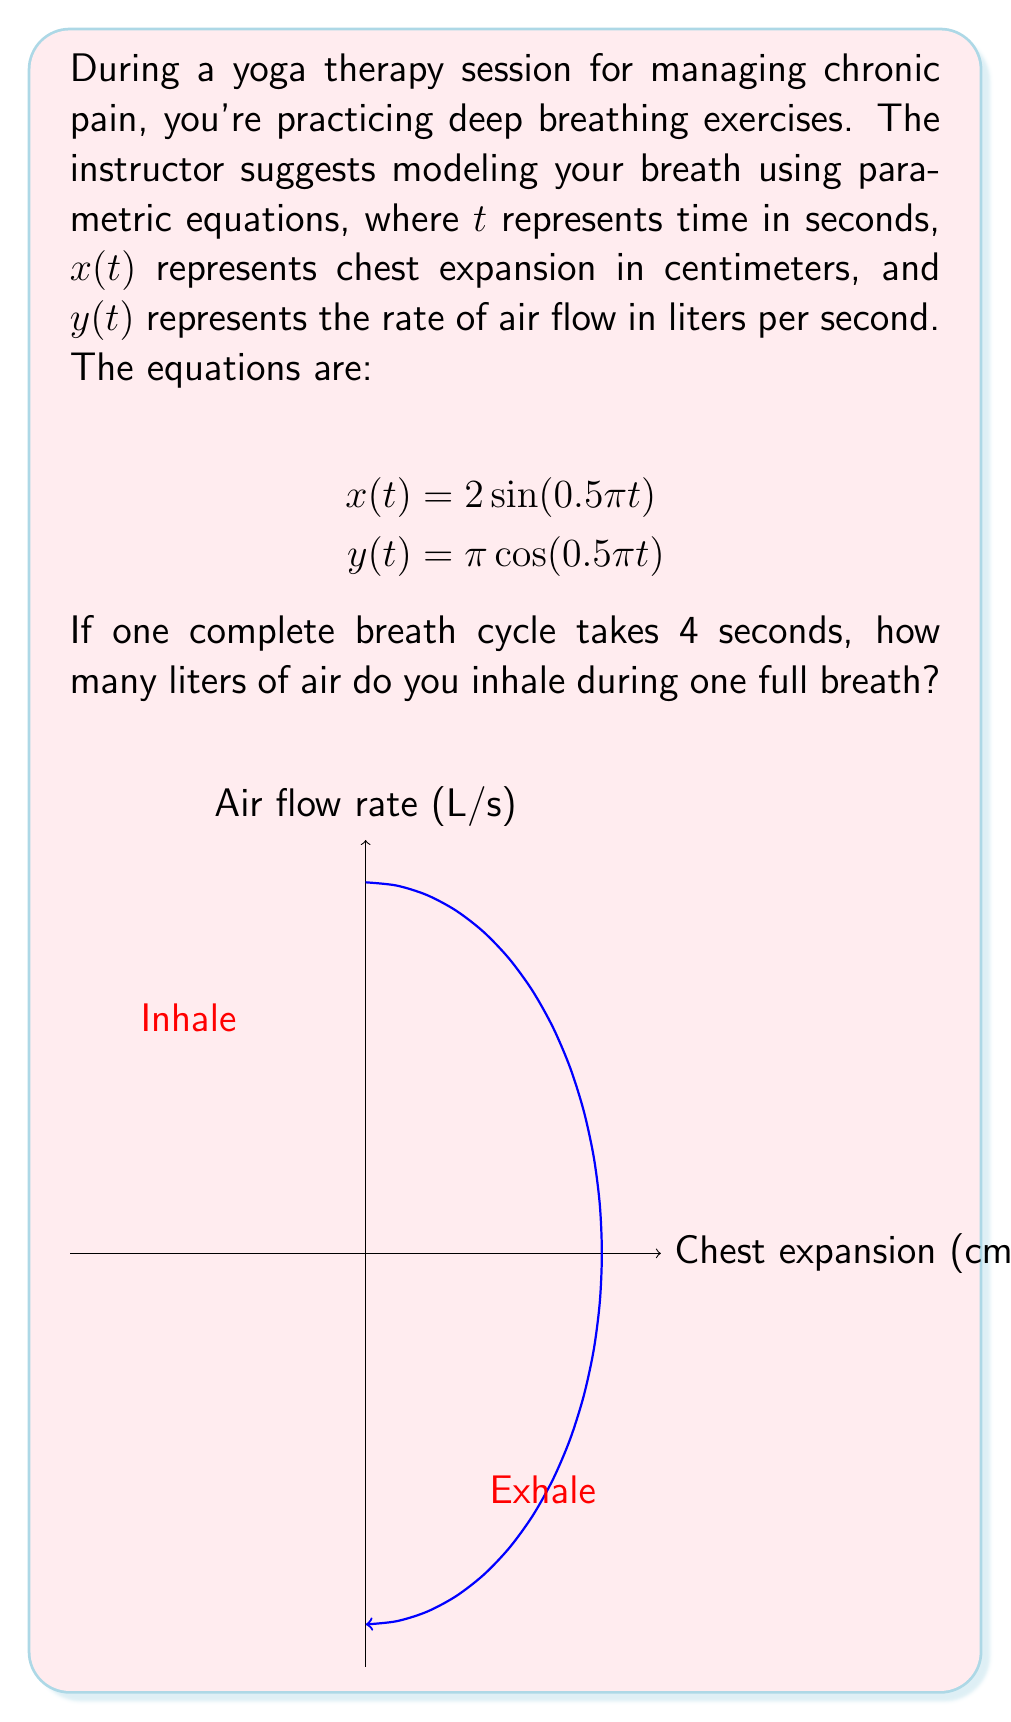What is the answer to this math problem? Let's approach this step-by-step:

1) First, we need to understand what the equations represent:
   - $x(t) = 2 \sin(0.5\pi t)$ represents chest expansion
   - $y(t) = \pi \cos(0.5\pi t)$ represents the rate of air flow

2) We're told that one complete breath cycle takes 4 seconds. This means that $t$ goes from 0 to 4 for a full cycle.

3) To find the volume of air inhaled, we need to integrate the air flow rate over the inhalation period. Inhalation occurs when the air flow rate is positive.

4) The air flow rate $y(t)$ is positive when $\cos(0.5\pi t)$ is positive, which is from $t=0$ to $t=2$ (half of the full cycle).

5) So, we need to integrate $y(t)$ from $t=0$ to $t=2$:

   $$\text{Volume} = \int_0^2 y(t) dt = \int_0^2 \pi \cos(0.5\pi t) dt$$

6) Solving this integral:
   $$\begin{align}
   \text{Volume} &= \pi \int_0^2 \cos(0.5\pi t) dt \\
   &= \pi \cdot \frac{2}{0.5\pi} \sin(0.5\pi t) \Big|_0^2 \\
   &= 2 \sin(\pi) - 2 \sin(0) \\
   &= 2 \cdot 0 - 2 \cdot 0 = 0
   \end{align}$$

7) This result of 0 makes sense because the volume inhaled equals the volume exhaled over a complete cycle.

8) To find just the inhaled volume, we need to take the absolute value inside the integral:

   $$\text{Inhaled Volume} = \int_0^2 |y(t)| dt = \int_0^2 \pi |\cos(0.5\pi t)| dt$$

9) This integral doesn't have a simple algebraic solution, but we can solve it numerically or recognize that it represents the area of one lobe of a sine curve with amplitude $\pi$ and period 4.

10) The area of one such lobe is equal to 4 (the amplitude multiplied by half the period).

Therefore, the volume of air inhaled during one full breath is 4 liters.
Answer: 4 liters 